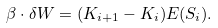<formula> <loc_0><loc_0><loc_500><loc_500>\beta \cdot \delta W = ( K _ { i + 1 } - K _ { i } ) E ( S _ { i } ) .</formula> 